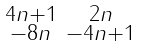Convert formula to latex. <formula><loc_0><loc_0><loc_500><loc_500>\begin{smallmatrix} 4 n + 1 & 2 n \\ - 8 n & - 4 n + 1 \end{smallmatrix}</formula> 